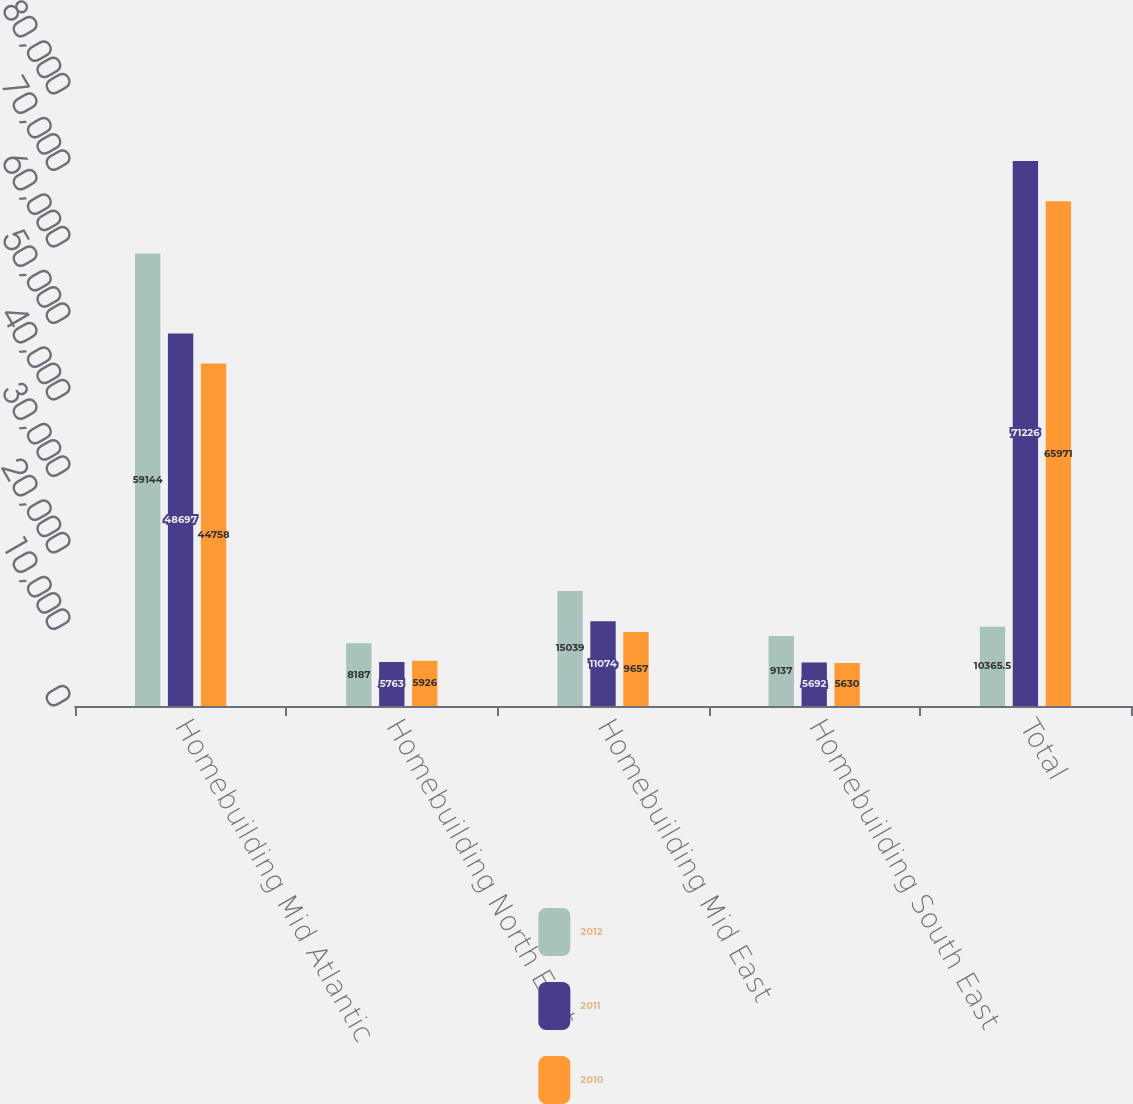<chart> <loc_0><loc_0><loc_500><loc_500><stacked_bar_chart><ecel><fcel>Homebuilding Mid Atlantic<fcel>Homebuilding North East<fcel>Homebuilding Mid East<fcel>Homebuilding South East<fcel>Total<nl><fcel>2012<fcel>59144<fcel>8187<fcel>15039<fcel>9137<fcel>10365.5<nl><fcel>2011<fcel>48697<fcel>5763<fcel>11074<fcel>5692<fcel>71226<nl><fcel>2010<fcel>44758<fcel>5926<fcel>9657<fcel>5630<fcel>65971<nl></chart> 